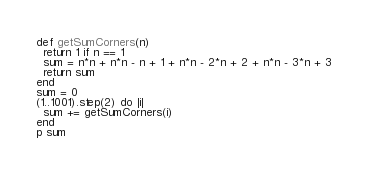<code> <loc_0><loc_0><loc_500><loc_500><_Ruby_>def getSumCorners(n) 
  return 1 if n == 1
  sum = n*n + n*n - n + 1 + n*n - 2*n + 2 + n*n - 3*n + 3
  return sum
end
sum = 0
(1..1001).step(2) do |i|
  sum += getSumCorners(i)
end
p sum
</code> 